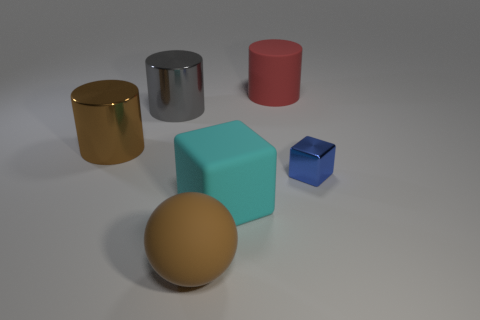Subtract all rubber cylinders. How many cylinders are left? 2 Add 1 small brown cubes. How many objects exist? 7 Subtract all cyan cubes. How many cubes are left? 1 Subtract all blocks. How many objects are left? 4 Subtract 3 cylinders. How many cylinders are left? 0 Add 3 blue metal blocks. How many blue metal blocks are left? 4 Add 3 purple blocks. How many purple blocks exist? 3 Subtract 0 yellow cubes. How many objects are left? 6 Subtract all gray cylinders. Subtract all brown balls. How many cylinders are left? 2 Subtract all purple balls. How many yellow cylinders are left? 0 